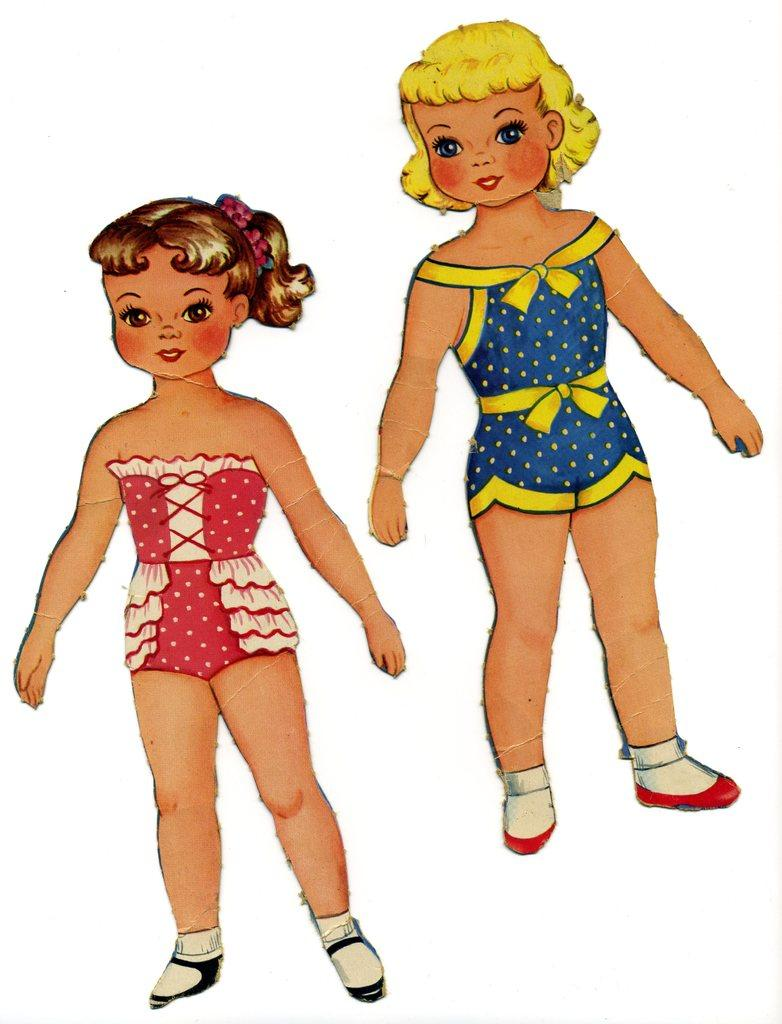What objects are present in the image? There are two doll stickers in the image. What is the background or surface on which the objects are placed? The stickers are on a white surface. What type of dress is the doll wearing in the image? There are no dolls present in the image, only stickers of dolls. Therefore, we cannot determine what type of dress the doll might be wearing. 